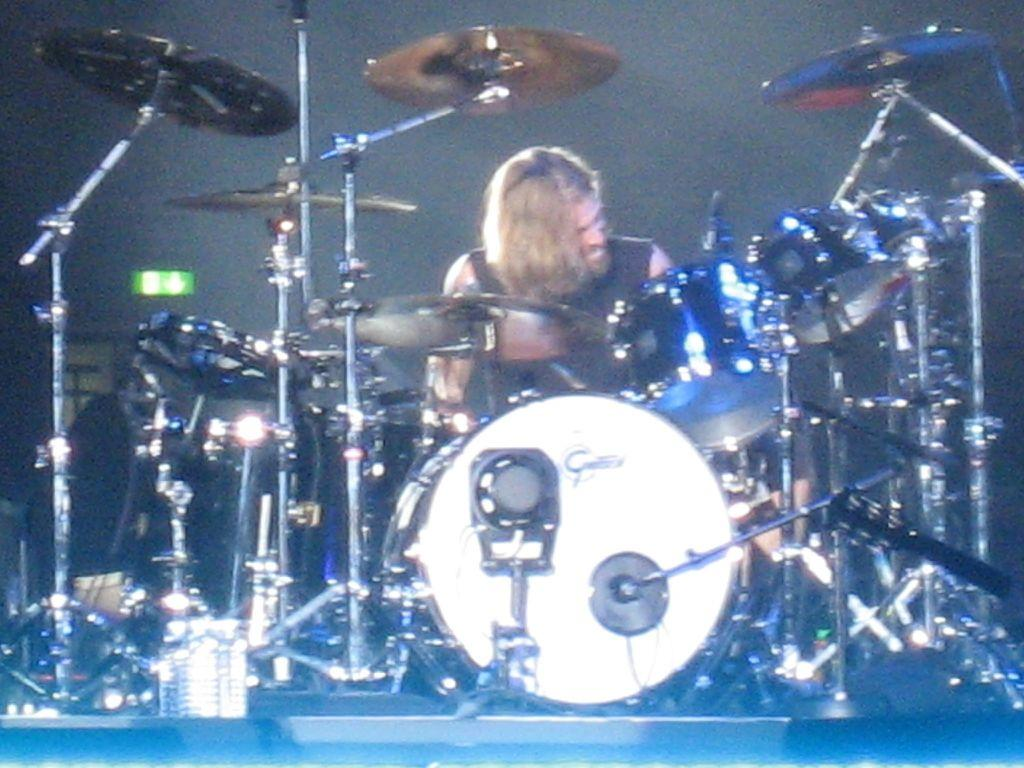Who or what is the main subject in the image? There is a person in the image. What is the person doing or standing near in the image? The person is in front of a drum set. Where is the drum set located in relation to the person? The drum set is in the foreground area of the image. What type of rabbit can be seen eating a cracker on top of the drum set in the image? There is no rabbit or cracker present on the drum set in the image. 